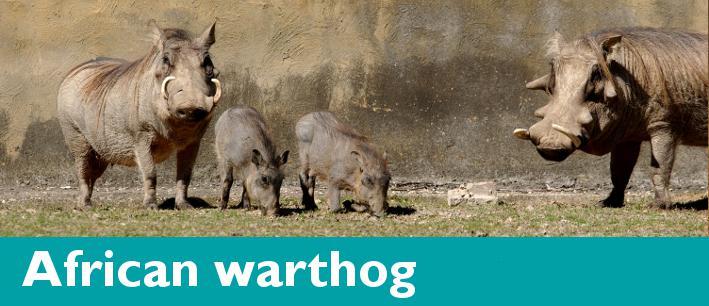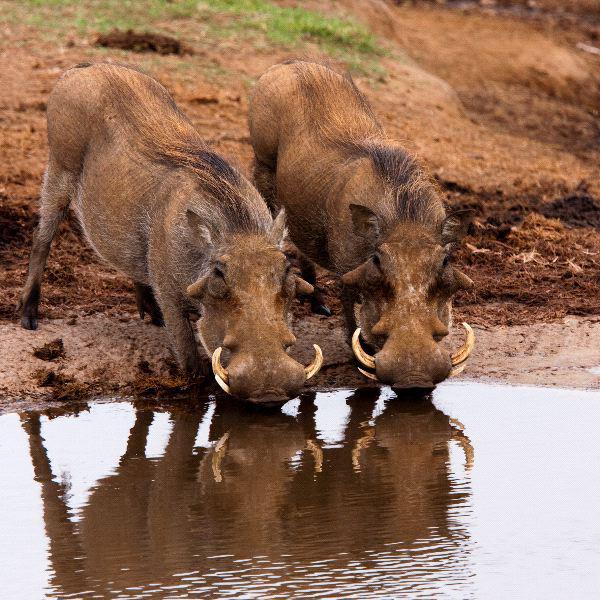The first image is the image on the left, the second image is the image on the right. For the images shown, is this caption "The right image contains exactly two warthogs." true? Answer yes or no. Yes. The first image is the image on the left, the second image is the image on the right. For the images shown, is this caption "One image shows exactly one pair of similarly-posed warthogs in a mostly brown scene." true? Answer yes or no. Yes. 